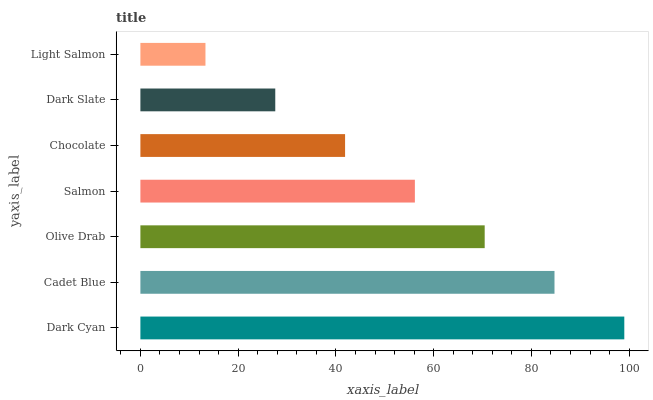Is Light Salmon the minimum?
Answer yes or no. Yes. Is Dark Cyan the maximum?
Answer yes or no. Yes. Is Cadet Blue the minimum?
Answer yes or no. No. Is Cadet Blue the maximum?
Answer yes or no. No. Is Dark Cyan greater than Cadet Blue?
Answer yes or no. Yes. Is Cadet Blue less than Dark Cyan?
Answer yes or no. Yes. Is Cadet Blue greater than Dark Cyan?
Answer yes or no. No. Is Dark Cyan less than Cadet Blue?
Answer yes or no. No. Is Salmon the high median?
Answer yes or no. Yes. Is Salmon the low median?
Answer yes or no. Yes. Is Cadet Blue the high median?
Answer yes or no. No. Is Olive Drab the low median?
Answer yes or no. No. 